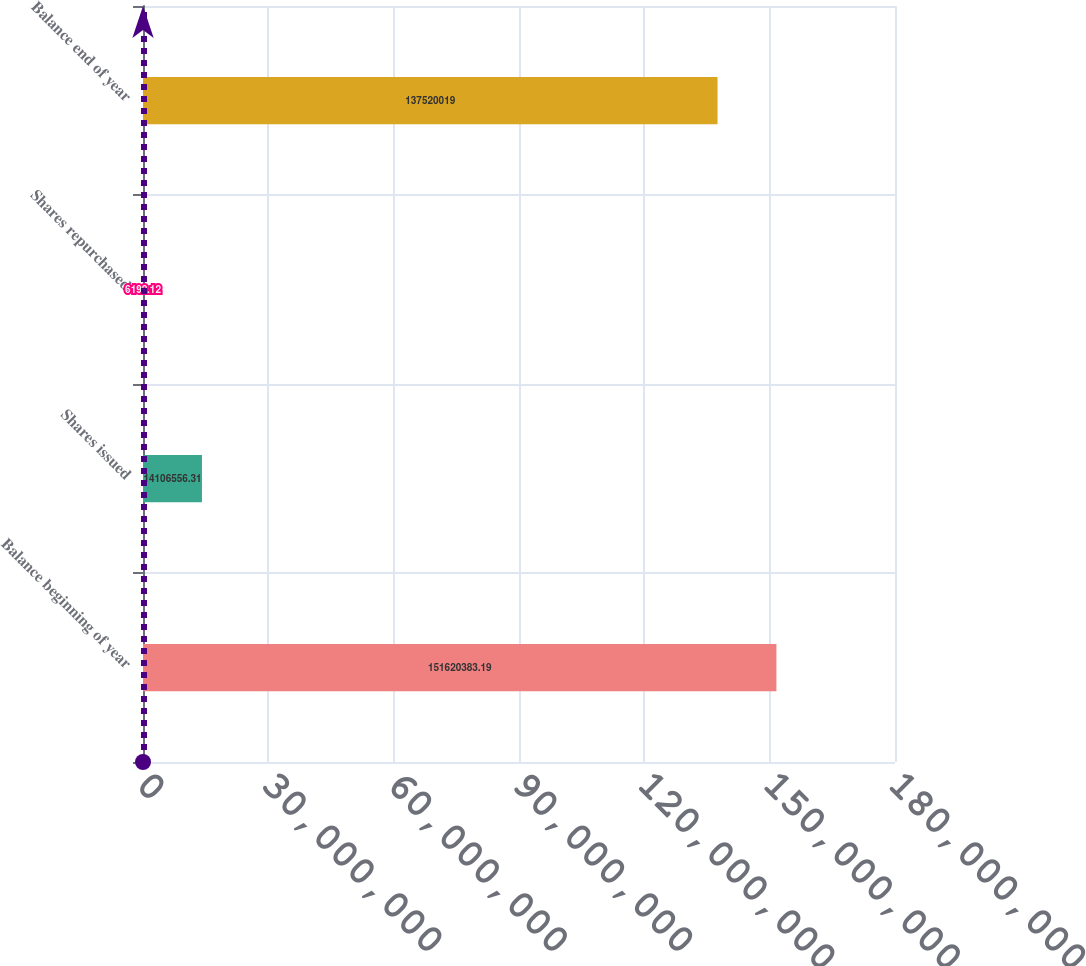<chart> <loc_0><loc_0><loc_500><loc_500><bar_chart><fcel>Balance beginning of year<fcel>Shares issued<fcel>Shares repurchased<fcel>Balance end of year<nl><fcel>1.5162e+08<fcel>1.41066e+07<fcel>6192.12<fcel>1.3752e+08<nl></chart> 